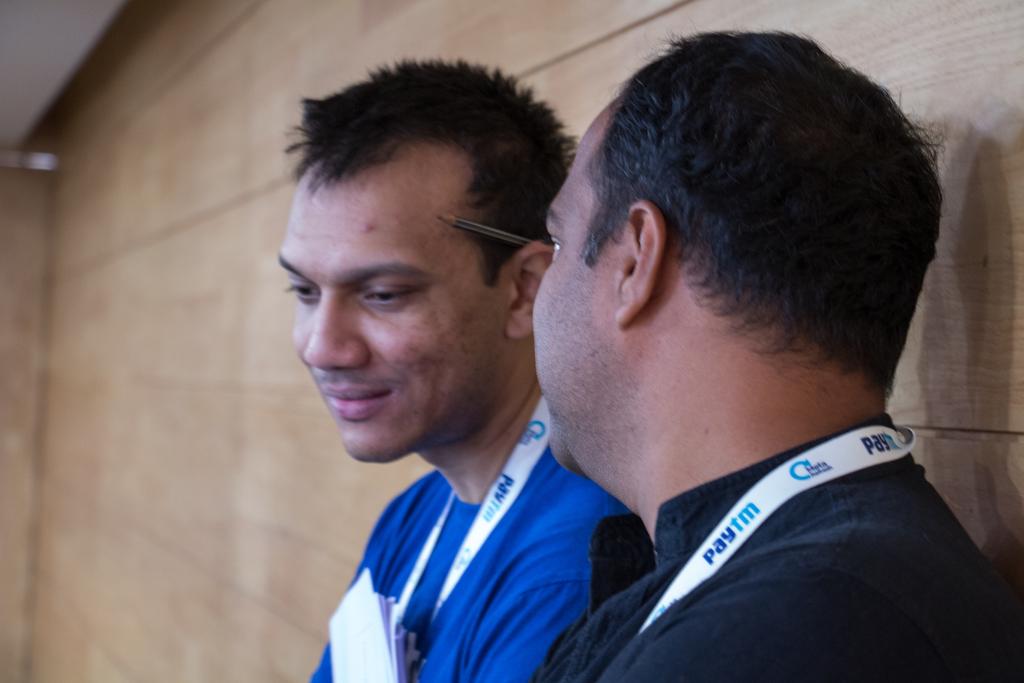What is on the lanyard?
Ensure brevity in your answer.  Paytm. 